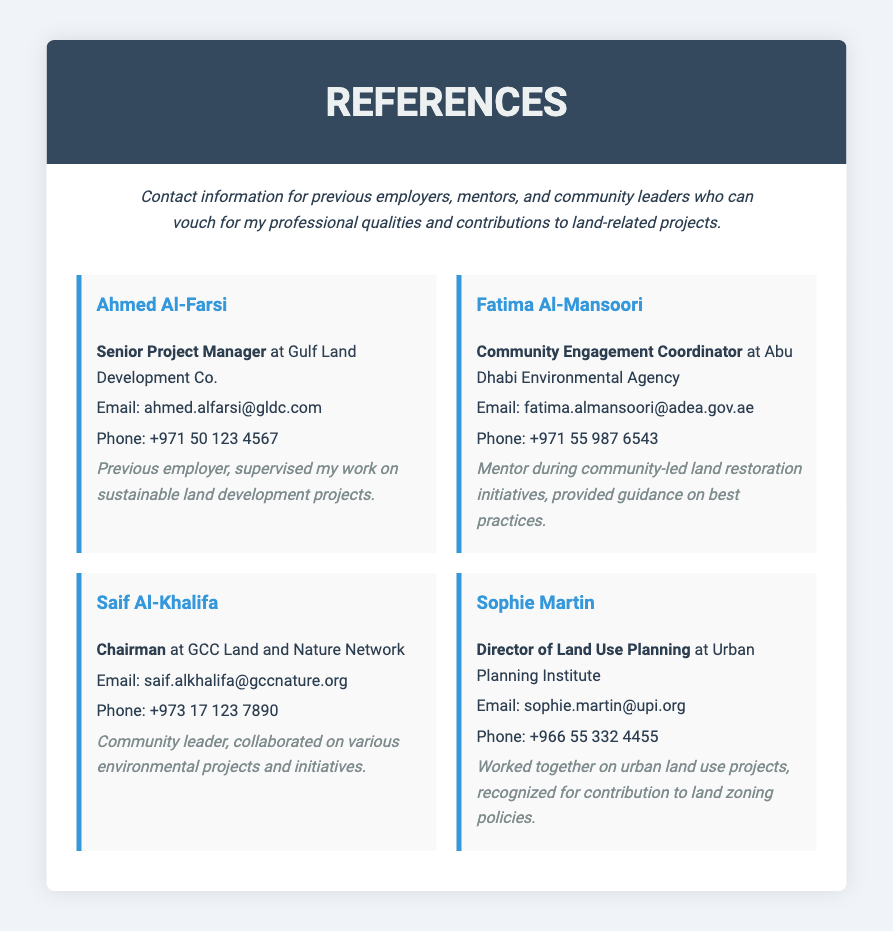what is the name of the first reference? The first reference listed in the document is Ahmed Al-Farsi.
Answer: Ahmed Al-Farsi what is the role of Fatima Al-Mansoori? Fatima Al-Mansoori is a Community Engagement Coordinator.
Answer: Community Engagement Coordinator how many references are listed in the document? There are four references provided in the document.
Answer: 4 what is the email address of Saif Al-Khalifa? The email address for Saif Al-Khalifa is saif.alkhalifa@gccnature.org.
Answer: saif.alkhalifa@gccnature.org what is the relationship between the author and Sophie Martin? The relationship is described as having worked together on urban land use projects.
Answer: Worked together on urban land use projects who provided guidance on best practices during community-led initiatives? Fatima Al-Mansoori mentored and provided guidance on best practices.
Answer: Fatima Al-Mansoori what organization does Ahmed Al-Farsi represent? Ahmed Al-Farsi is associated with Gulf Land Development Co.
Answer: Gulf Land Development Co which reference is a community leader? Saif Al-Khalifa is identified as a community leader.
Answer: Saif Al-Khalifa what is the phone number for Sophie Martin? Sophie Martin's phone number is +966 55 332 4455.
Answer: +966 55 332 4455 